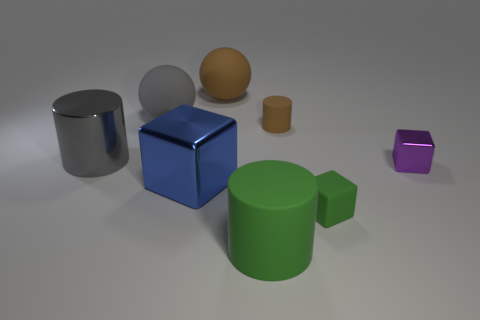Are there fewer large brown matte objects that are behind the big brown rubber thing than brown rubber things?
Your response must be concise. Yes. What number of cylinders have the same size as the green matte cube?
Ensure brevity in your answer.  1. What is the shape of the large object that is the same color as the matte cube?
Offer a terse response. Cylinder. What shape is the small object in front of the metal thing to the right of the metallic thing in front of the small purple cube?
Provide a short and direct response. Cube. What color is the rubber object that is behind the big gray rubber ball?
Offer a very short reply. Brown. What number of things are metal things that are on the left side of the tiny purple object or big things that are on the right side of the blue metallic block?
Offer a very short reply. 4. What number of other rubber objects are the same shape as the big blue object?
Keep it short and to the point. 1. What color is the metallic cylinder that is the same size as the brown matte sphere?
Your response must be concise. Gray. What is the color of the matte cylinder that is in front of the matte cylinder that is behind the metallic thing that is on the left side of the blue metal block?
Ensure brevity in your answer.  Green. There is a blue object; does it have the same size as the cylinder to the right of the large green thing?
Keep it short and to the point. No. 